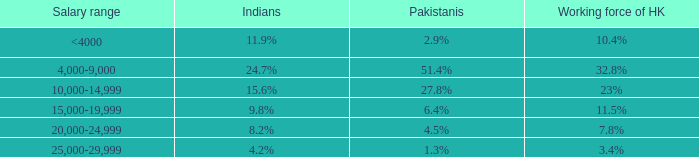Given that 37.1% is the nepalese proportion, what is the total labor force in hong kong? 23%. 